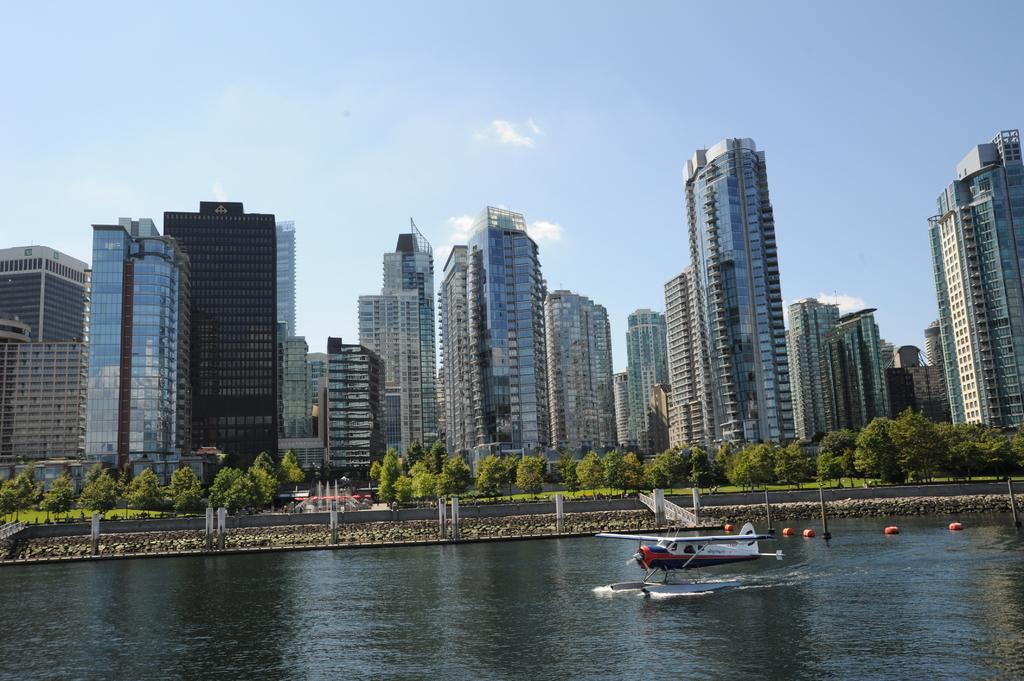What is the main subject of the image? The main subject of the image is a helicopter in the water. What can be seen in the middle of the image? There is a bridge at the center of the image. What type of vegetation is visible in the background of the image? There are trees in the background of the image. What else can be seen in the background of the image? There are buildings and the sky visible in the background of the image. How many balls are being juggled by the sheep in the image? There are no balls or sheep present in the image. 